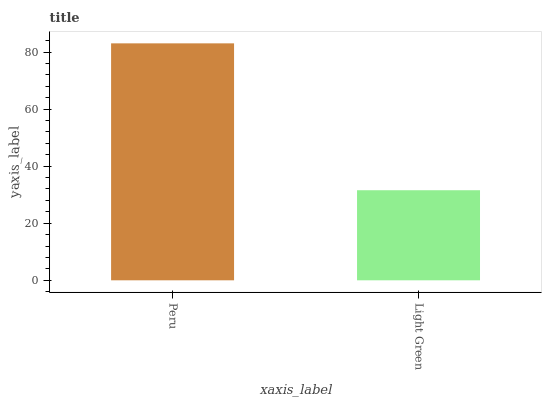Is Light Green the maximum?
Answer yes or no. No. Is Peru greater than Light Green?
Answer yes or no. Yes. Is Light Green less than Peru?
Answer yes or no. Yes. Is Light Green greater than Peru?
Answer yes or no. No. Is Peru less than Light Green?
Answer yes or no. No. Is Peru the high median?
Answer yes or no. Yes. Is Light Green the low median?
Answer yes or no. Yes. Is Light Green the high median?
Answer yes or no. No. Is Peru the low median?
Answer yes or no. No. 